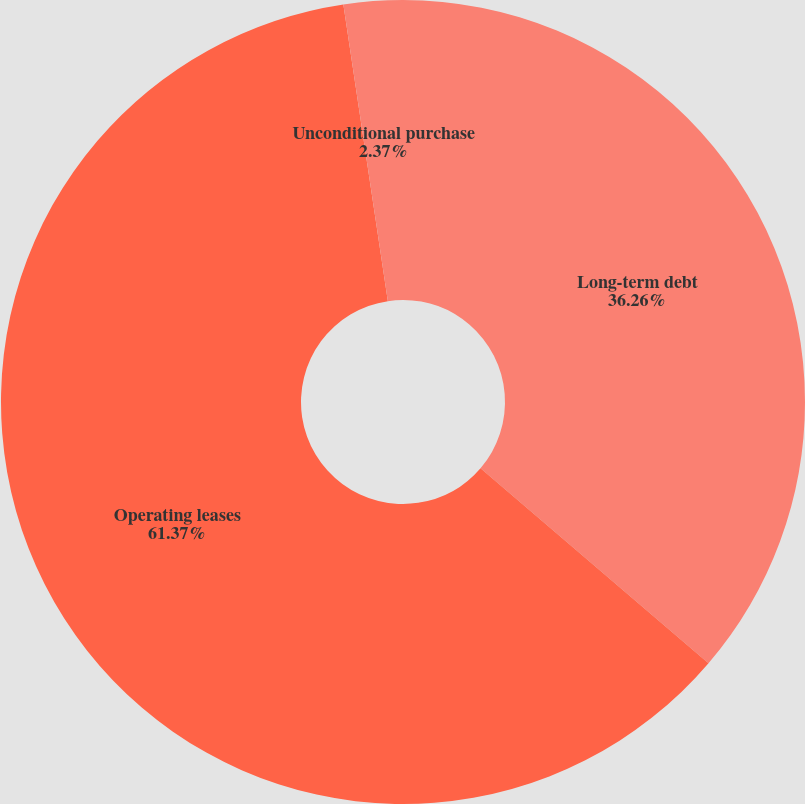Convert chart to OTSL. <chart><loc_0><loc_0><loc_500><loc_500><pie_chart><fcel>Long-term debt<fcel>Operating leases<fcel>Unconditional purchase<nl><fcel>36.26%<fcel>61.37%<fcel>2.37%<nl></chart> 